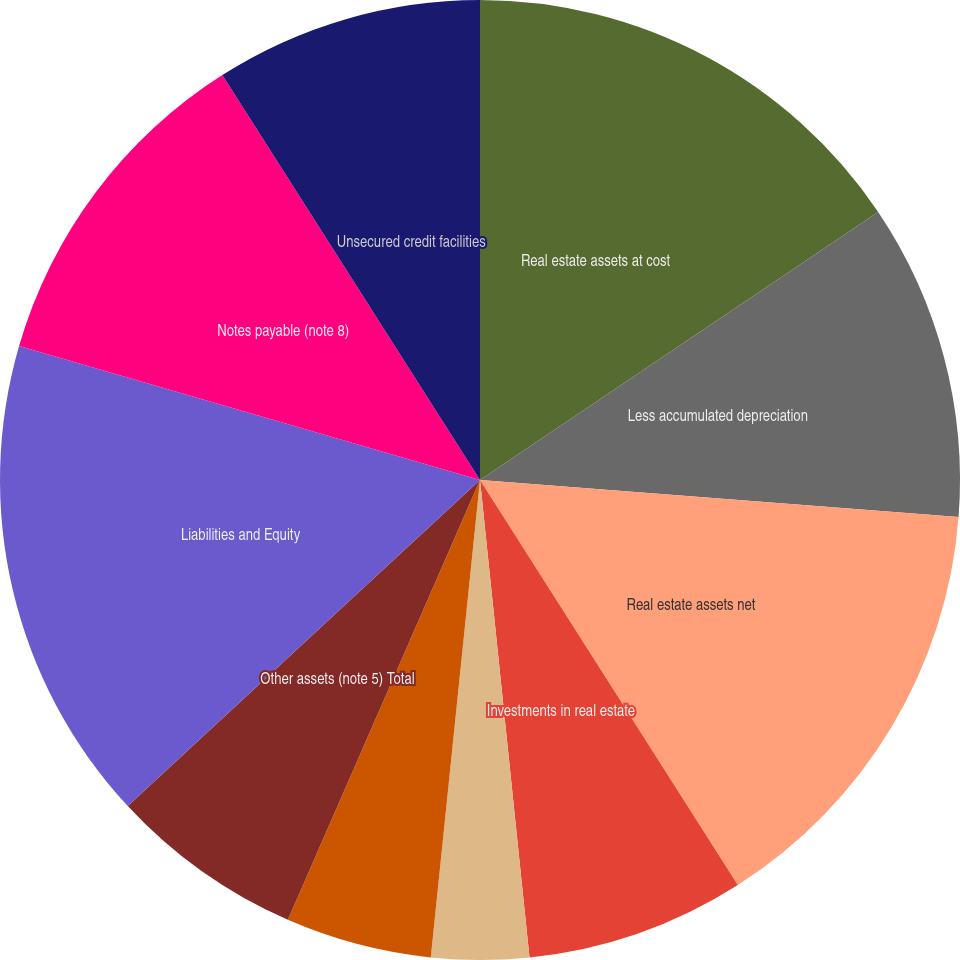Convert chart to OTSL. <chart><loc_0><loc_0><loc_500><loc_500><pie_chart><fcel>Real estate assets at cost<fcel>Less accumulated depreciation<fcel>Real estate assets net<fcel>Investments in real estate<fcel>Cash and cash equivalents<fcel>Tenant and other receivables<fcel>Other assets (note 5) Total<fcel>Liabilities and Equity<fcel>Notes payable (note 8)<fcel>Unsecured credit facilities<nl><fcel>15.57%<fcel>10.66%<fcel>14.75%<fcel>7.38%<fcel>3.28%<fcel>4.92%<fcel>6.56%<fcel>16.39%<fcel>11.48%<fcel>9.02%<nl></chart> 